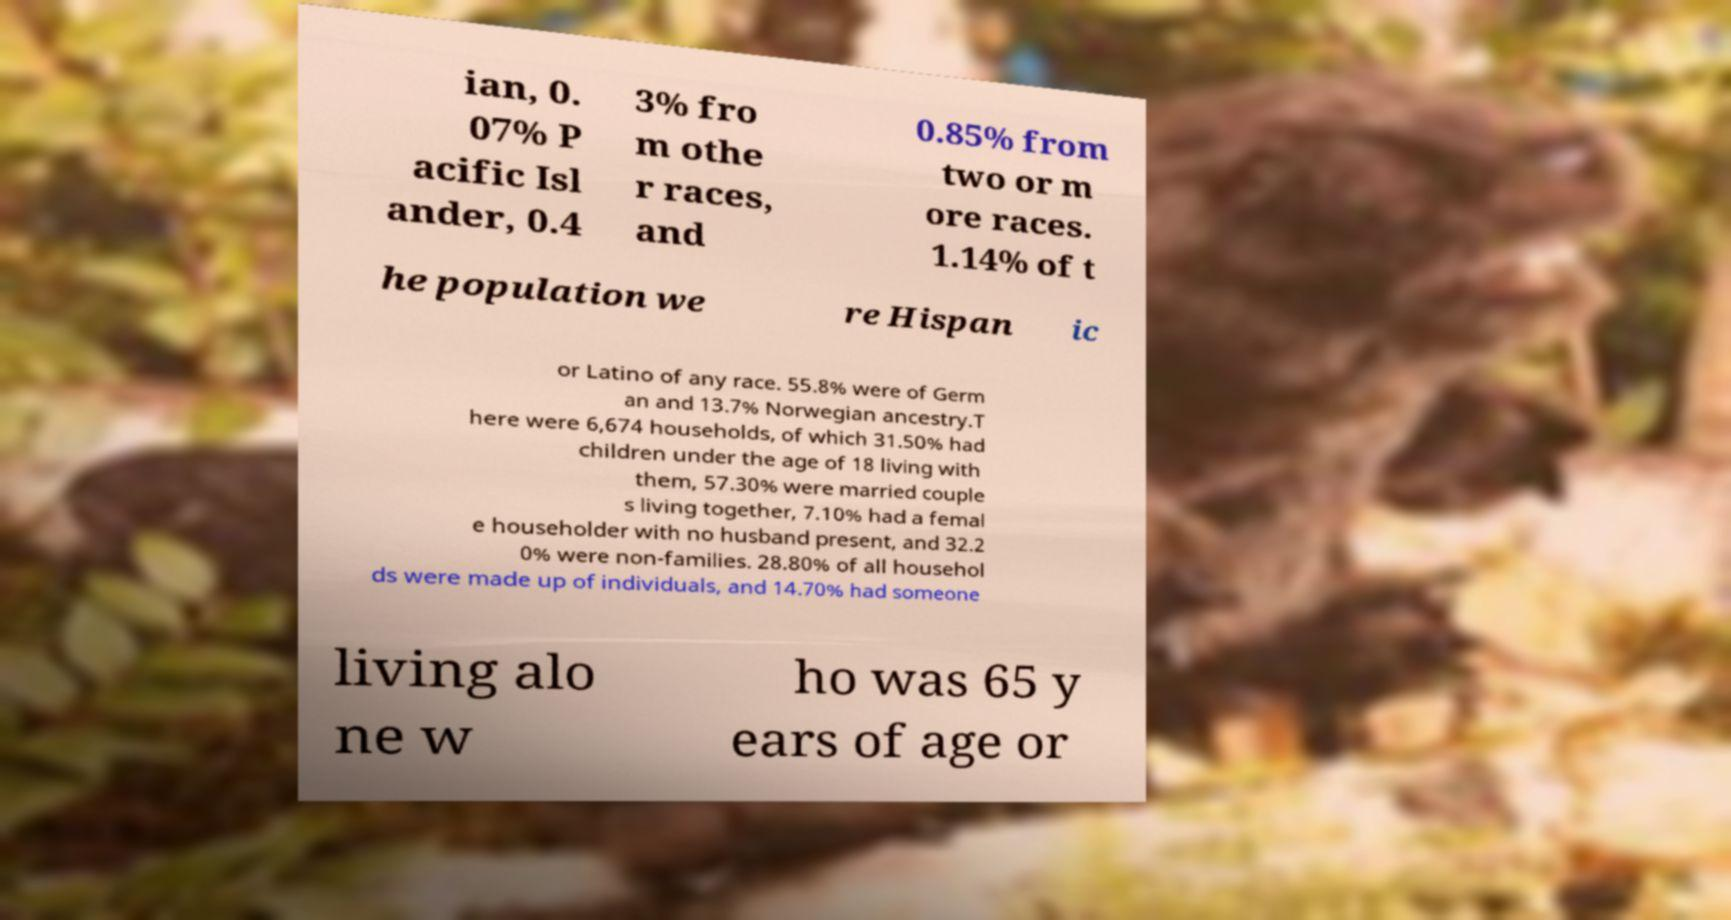I need the written content from this picture converted into text. Can you do that? ian, 0. 07% P acific Isl ander, 0.4 3% fro m othe r races, and 0.85% from two or m ore races. 1.14% of t he population we re Hispan ic or Latino of any race. 55.8% were of Germ an and 13.7% Norwegian ancestry.T here were 6,674 households, of which 31.50% had children under the age of 18 living with them, 57.30% were married couple s living together, 7.10% had a femal e householder with no husband present, and 32.2 0% were non-families. 28.80% of all househol ds were made up of individuals, and 14.70% had someone living alo ne w ho was 65 y ears of age or 